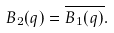<formula> <loc_0><loc_0><loc_500><loc_500>B _ { 2 } ( q ) = \overline { B _ { 1 } ( q ) } .</formula> 